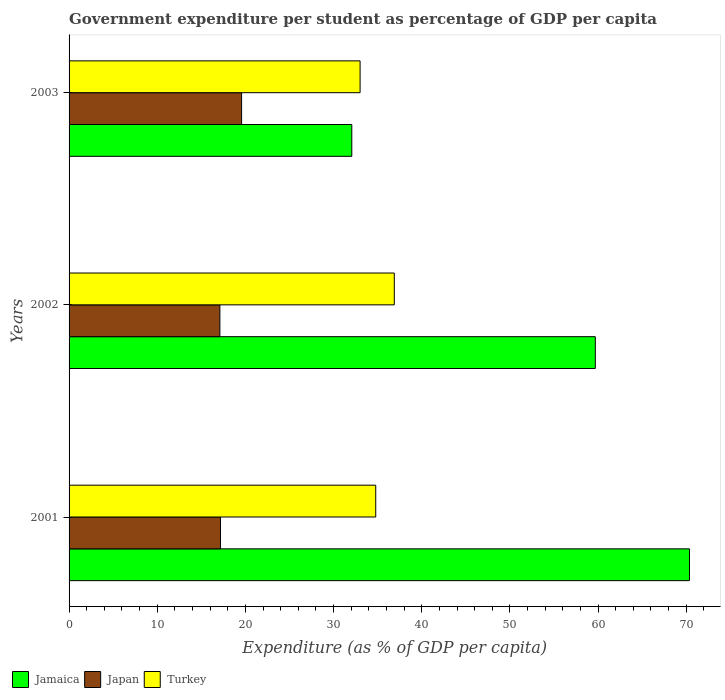How many different coloured bars are there?
Your response must be concise. 3. How many groups of bars are there?
Your response must be concise. 3. What is the label of the 1st group of bars from the top?
Ensure brevity in your answer.  2003. What is the percentage of expenditure per student in Jamaica in 2001?
Give a very brief answer. 70.37. Across all years, what is the maximum percentage of expenditure per student in Jamaica?
Provide a succinct answer. 70.37. Across all years, what is the minimum percentage of expenditure per student in Turkey?
Your answer should be compact. 33.01. In which year was the percentage of expenditure per student in Turkey minimum?
Give a very brief answer. 2003. What is the total percentage of expenditure per student in Jamaica in the graph?
Offer a terse response. 162.12. What is the difference between the percentage of expenditure per student in Jamaica in 2002 and that in 2003?
Provide a short and direct response. 27.62. What is the difference between the percentage of expenditure per student in Japan in 2003 and the percentage of expenditure per student in Jamaica in 2002?
Your answer should be very brief. -40.12. What is the average percentage of expenditure per student in Turkey per year?
Your answer should be compact. 34.89. In the year 2002, what is the difference between the percentage of expenditure per student in Turkey and percentage of expenditure per student in Japan?
Provide a succinct answer. 19.78. What is the ratio of the percentage of expenditure per student in Japan in 2002 to that in 2003?
Give a very brief answer. 0.87. Is the difference between the percentage of expenditure per student in Turkey in 2001 and 2002 greater than the difference between the percentage of expenditure per student in Japan in 2001 and 2002?
Offer a very short reply. No. What is the difference between the highest and the second highest percentage of expenditure per student in Jamaica?
Keep it short and to the point. 10.68. What is the difference between the highest and the lowest percentage of expenditure per student in Japan?
Your response must be concise. 2.46. In how many years, is the percentage of expenditure per student in Turkey greater than the average percentage of expenditure per student in Turkey taken over all years?
Make the answer very short. 1. Is the sum of the percentage of expenditure per student in Japan in 2001 and 2002 greater than the maximum percentage of expenditure per student in Jamaica across all years?
Provide a succinct answer. No. What does the 3rd bar from the bottom in 2003 represents?
Offer a very short reply. Turkey. How many bars are there?
Ensure brevity in your answer.  9. Are all the bars in the graph horizontal?
Offer a very short reply. Yes. How many years are there in the graph?
Your answer should be compact. 3. Does the graph contain any zero values?
Provide a succinct answer. No. Does the graph contain grids?
Ensure brevity in your answer.  No. Where does the legend appear in the graph?
Your answer should be compact. Bottom left. How are the legend labels stacked?
Give a very brief answer. Horizontal. What is the title of the graph?
Your response must be concise. Government expenditure per student as percentage of GDP per capita. What is the label or title of the X-axis?
Make the answer very short. Expenditure (as % of GDP per capita). What is the Expenditure (as % of GDP per capita) of Jamaica in 2001?
Offer a terse response. 70.37. What is the Expenditure (as % of GDP per capita) of Japan in 2001?
Provide a short and direct response. 17.18. What is the Expenditure (as % of GDP per capita) in Turkey in 2001?
Offer a terse response. 34.78. What is the Expenditure (as % of GDP per capita) of Jamaica in 2002?
Ensure brevity in your answer.  59.69. What is the Expenditure (as % of GDP per capita) in Japan in 2002?
Make the answer very short. 17.1. What is the Expenditure (as % of GDP per capita) in Turkey in 2002?
Offer a very short reply. 36.89. What is the Expenditure (as % of GDP per capita) in Jamaica in 2003?
Provide a short and direct response. 32.07. What is the Expenditure (as % of GDP per capita) of Japan in 2003?
Your response must be concise. 19.57. What is the Expenditure (as % of GDP per capita) in Turkey in 2003?
Ensure brevity in your answer.  33.01. Across all years, what is the maximum Expenditure (as % of GDP per capita) of Jamaica?
Ensure brevity in your answer.  70.37. Across all years, what is the maximum Expenditure (as % of GDP per capita) in Japan?
Make the answer very short. 19.57. Across all years, what is the maximum Expenditure (as % of GDP per capita) in Turkey?
Provide a succinct answer. 36.89. Across all years, what is the minimum Expenditure (as % of GDP per capita) in Jamaica?
Give a very brief answer. 32.07. Across all years, what is the minimum Expenditure (as % of GDP per capita) in Japan?
Your answer should be compact. 17.1. Across all years, what is the minimum Expenditure (as % of GDP per capita) of Turkey?
Your answer should be very brief. 33.01. What is the total Expenditure (as % of GDP per capita) of Jamaica in the graph?
Your response must be concise. 162.12. What is the total Expenditure (as % of GDP per capita) in Japan in the graph?
Provide a succinct answer. 53.85. What is the total Expenditure (as % of GDP per capita) of Turkey in the graph?
Provide a short and direct response. 104.68. What is the difference between the Expenditure (as % of GDP per capita) of Jamaica in 2001 and that in 2002?
Offer a very short reply. 10.68. What is the difference between the Expenditure (as % of GDP per capita) in Japan in 2001 and that in 2002?
Ensure brevity in your answer.  0.07. What is the difference between the Expenditure (as % of GDP per capita) of Turkey in 2001 and that in 2002?
Offer a terse response. -2.1. What is the difference between the Expenditure (as % of GDP per capita) of Jamaica in 2001 and that in 2003?
Ensure brevity in your answer.  38.3. What is the difference between the Expenditure (as % of GDP per capita) of Japan in 2001 and that in 2003?
Offer a very short reply. -2.39. What is the difference between the Expenditure (as % of GDP per capita) in Turkey in 2001 and that in 2003?
Make the answer very short. 1.77. What is the difference between the Expenditure (as % of GDP per capita) in Jamaica in 2002 and that in 2003?
Your answer should be compact. 27.62. What is the difference between the Expenditure (as % of GDP per capita) of Japan in 2002 and that in 2003?
Your answer should be compact. -2.46. What is the difference between the Expenditure (as % of GDP per capita) of Turkey in 2002 and that in 2003?
Your answer should be compact. 3.88. What is the difference between the Expenditure (as % of GDP per capita) in Jamaica in 2001 and the Expenditure (as % of GDP per capita) in Japan in 2002?
Provide a succinct answer. 53.26. What is the difference between the Expenditure (as % of GDP per capita) of Jamaica in 2001 and the Expenditure (as % of GDP per capita) of Turkey in 2002?
Make the answer very short. 33.48. What is the difference between the Expenditure (as % of GDP per capita) of Japan in 2001 and the Expenditure (as % of GDP per capita) of Turkey in 2002?
Ensure brevity in your answer.  -19.71. What is the difference between the Expenditure (as % of GDP per capita) of Jamaica in 2001 and the Expenditure (as % of GDP per capita) of Japan in 2003?
Provide a succinct answer. 50.8. What is the difference between the Expenditure (as % of GDP per capita) of Jamaica in 2001 and the Expenditure (as % of GDP per capita) of Turkey in 2003?
Provide a succinct answer. 37.36. What is the difference between the Expenditure (as % of GDP per capita) of Japan in 2001 and the Expenditure (as % of GDP per capita) of Turkey in 2003?
Your answer should be compact. -15.83. What is the difference between the Expenditure (as % of GDP per capita) of Jamaica in 2002 and the Expenditure (as % of GDP per capita) of Japan in 2003?
Make the answer very short. 40.12. What is the difference between the Expenditure (as % of GDP per capita) of Jamaica in 2002 and the Expenditure (as % of GDP per capita) of Turkey in 2003?
Your response must be concise. 26.68. What is the difference between the Expenditure (as % of GDP per capita) of Japan in 2002 and the Expenditure (as % of GDP per capita) of Turkey in 2003?
Your response must be concise. -15.9. What is the average Expenditure (as % of GDP per capita) in Jamaica per year?
Give a very brief answer. 54.04. What is the average Expenditure (as % of GDP per capita) in Japan per year?
Your response must be concise. 17.95. What is the average Expenditure (as % of GDP per capita) in Turkey per year?
Keep it short and to the point. 34.89. In the year 2001, what is the difference between the Expenditure (as % of GDP per capita) in Jamaica and Expenditure (as % of GDP per capita) in Japan?
Ensure brevity in your answer.  53.19. In the year 2001, what is the difference between the Expenditure (as % of GDP per capita) in Jamaica and Expenditure (as % of GDP per capita) in Turkey?
Keep it short and to the point. 35.58. In the year 2001, what is the difference between the Expenditure (as % of GDP per capita) in Japan and Expenditure (as % of GDP per capita) in Turkey?
Give a very brief answer. -17.61. In the year 2002, what is the difference between the Expenditure (as % of GDP per capita) in Jamaica and Expenditure (as % of GDP per capita) in Japan?
Keep it short and to the point. 42.58. In the year 2002, what is the difference between the Expenditure (as % of GDP per capita) of Jamaica and Expenditure (as % of GDP per capita) of Turkey?
Your answer should be very brief. 22.8. In the year 2002, what is the difference between the Expenditure (as % of GDP per capita) of Japan and Expenditure (as % of GDP per capita) of Turkey?
Provide a short and direct response. -19.78. In the year 2003, what is the difference between the Expenditure (as % of GDP per capita) of Jamaica and Expenditure (as % of GDP per capita) of Japan?
Your answer should be compact. 12.5. In the year 2003, what is the difference between the Expenditure (as % of GDP per capita) in Jamaica and Expenditure (as % of GDP per capita) in Turkey?
Offer a very short reply. -0.94. In the year 2003, what is the difference between the Expenditure (as % of GDP per capita) in Japan and Expenditure (as % of GDP per capita) in Turkey?
Offer a terse response. -13.44. What is the ratio of the Expenditure (as % of GDP per capita) in Jamaica in 2001 to that in 2002?
Keep it short and to the point. 1.18. What is the ratio of the Expenditure (as % of GDP per capita) of Japan in 2001 to that in 2002?
Your answer should be very brief. 1. What is the ratio of the Expenditure (as % of GDP per capita) of Turkey in 2001 to that in 2002?
Offer a very short reply. 0.94. What is the ratio of the Expenditure (as % of GDP per capita) of Jamaica in 2001 to that in 2003?
Provide a short and direct response. 2.19. What is the ratio of the Expenditure (as % of GDP per capita) in Japan in 2001 to that in 2003?
Ensure brevity in your answer.  0.88. What is the ratio of the Expenditure (as % of GDP per capita) of Turkey in 2001 to that in 2003?
Ensure brevity in your answer.  1.05. What is the ratio of the Expenditure (as % of GDP per capita) of Jamaica in 2002 to that in 2003?
Make the answer very short. 1.86. What is the ratio of the Expenditure (as % of GDP per capita) of Japan in 2002 to that in 2003?
Your answer should be compact. 0.87. What is the ratio of the Expenditure (as % of GDP per capita) in Turkey in 2002 to that in 2003?
Provide a succinct answer. 1.12. What is the difference between the highest and the second highest Expenditure (as % of GDP per capita) of Jamaica?
Provide a short and direct response. 10.68. What is the difference between the highest and the second highest Expenditure (as % of GDP per capita) in Japan?
Your response must be concise. 2.39. What is the difference between the highest and the second highest Expenditure (as % of GDP per capita) of Turkey?
Your answer should be compact. 2.1. What is the difference between the highest and the lowest Expenditure (as % of GDP per capita) in Jamaica?
Offer a very short reply. 38.3. What is the difference between the highest and the lowest Expenditure (as % of GDP per capita) of Japan?
Your answer should be very brief. 2.46. What is the difference between the highest and the lowest Expenditure (as % of GDP per capita) in Turkey?
Give a very brief answer. 3.88. 